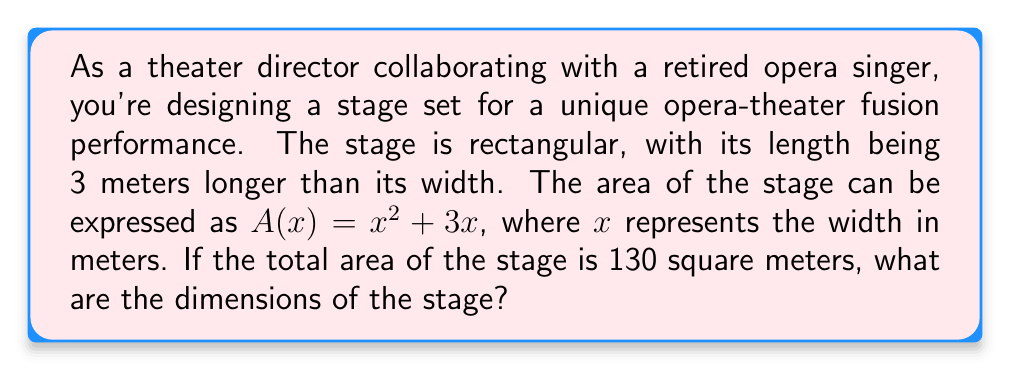Solve this math problem. Let's approach this step-by-step:

1) We're given that the area of the stage is represented by the polynomial $A(x) = x^2 + 3x$, where $x$ is the width.

2) We're also told that the total area is 130 square meters. So we can set up the equation:

   $x^2 + 3x = 130$

3) This is a quadratic equation. To solve it, let's rearrange it into standard form:

   $x^2 + 3x - 130 = 0$

4) We can solve this using the quadratic formula: $x = \frac{-b \pm \sqrt{b^2 - 4ac}}{2a}$

   Where $a = 1$, $b = 3$, and $c = -130$

5) Plugging these values into the quadratic formula:

   $x = \frac{-3 \pm \sqrt{3^2 - 4(1)(-130)}}{2(1)}$

   $= \frac{-3 \pm \sqrt{9 + 520}}{2}$

   $= \frac{-3 \pm \sqrt{529}}{2}$

   $= \frac{-3 \pm 23}{2}$

6) This gives us two solutions:

   $x = \frac{-3 + 23}{2} = 10$ or $x = \frac{-3 - 23}{2} = -13$

7) Since width cannot be negative, we take the positive solution: $x = 10$ meters.

8) Remember, the length is 3 meters longer than the width. So the length is $10 + 3 = 13$ meters.

Therefore, the dimensions of the stage are 10 meters wide and 13 meters long.
Answer: The stage is 10 meters wide and 13 meters long. 